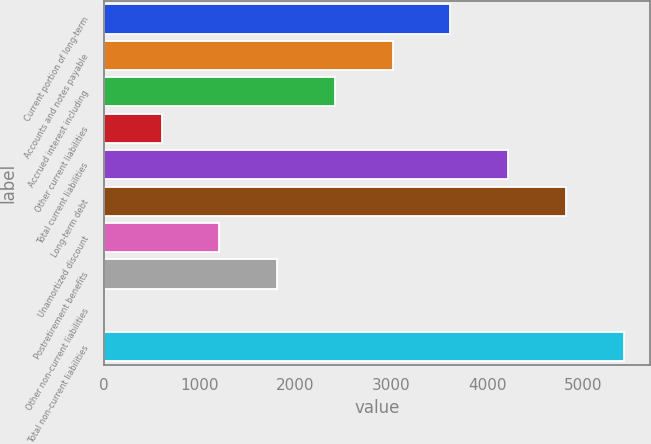<chart> <loc_0><loc_0><loc_500><loc_500><bar_chart><fcel>Current portion of long-term<fcel>Accounts and notes payable<fcel>Accrued interest including<fcel>Other current liabilities<fcel>Total current liabilities<fcel>Long-term debt<fcel>Unamortized discount<fcel>Postretirement benefits<fcel>Other non-current liabilities<fcel>Total non-current liabilities<nl><fcel>3617<fcel>3014.5<fcel>2412<fcel>604.5<fcel>4219.5<fcel>4822<fcel>1207<fcel>1809.5<fcel>2<fcel>5424.5<nl></chart> 